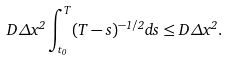Convert formula to latex. <formula><loc_0><loc_0><loc_500><loc_500>D \Delta x ^ { 2 } \int _ { t _ { 0 } } ^ { T } ( T - s ) ^ { - 1 / 2 } d s \leq D \Delta x ^ { 2 } .</formula> 